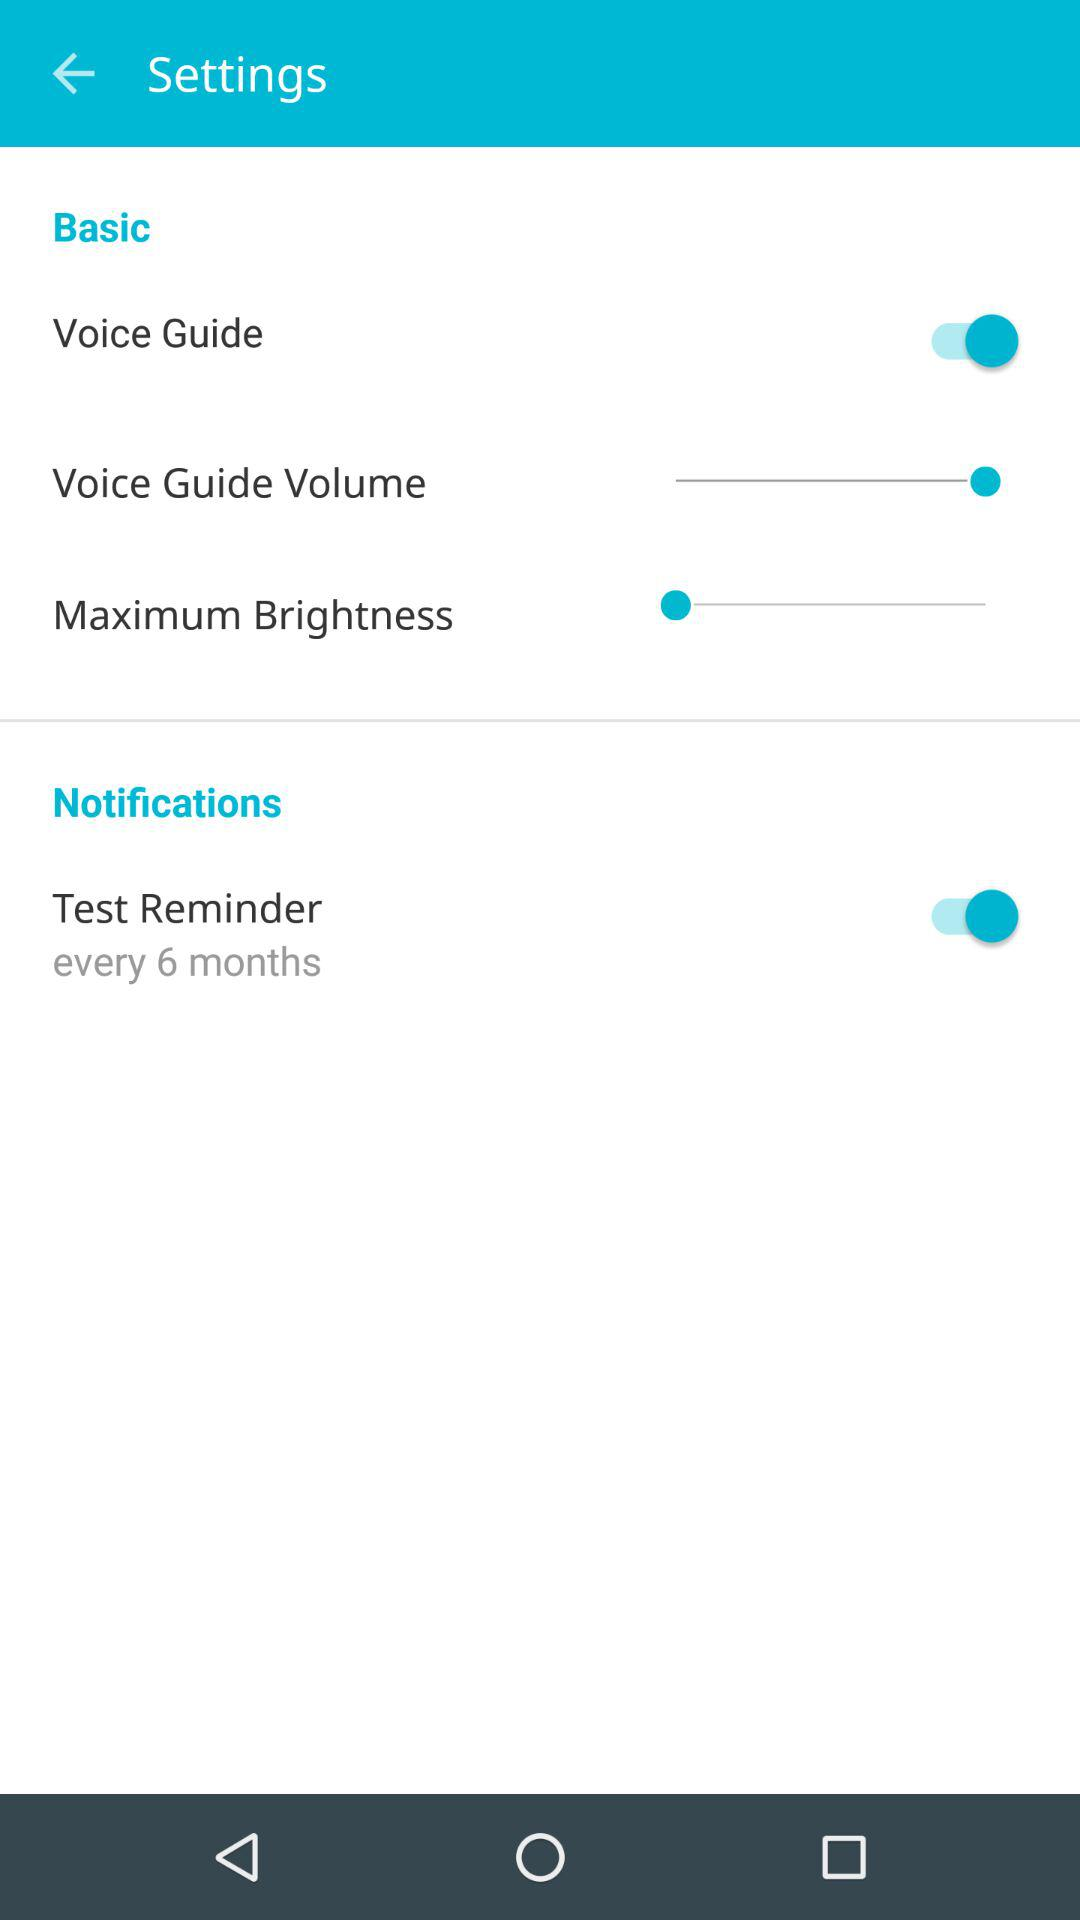What is the status of "Test Reminder"? The status is "on". 